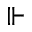Convert formula to latex. <formula><loc_0><loc_0><loc_500><loc_500>\ V d a s h</formula> 